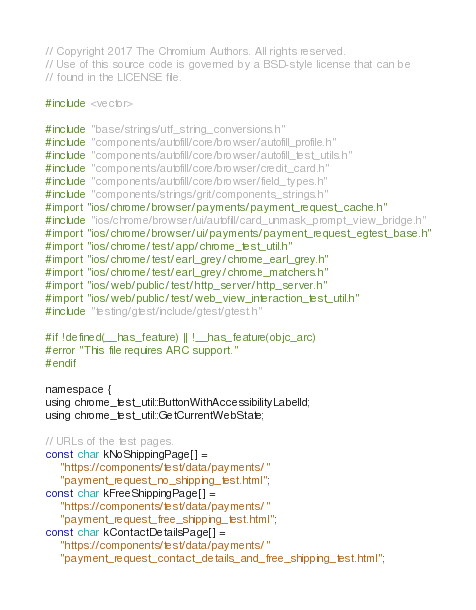Convert code to text. <code><loc_0><loc_0><loc_500><loc_500><_ObjectiveC_>// Copyright 2017 The Chromium Authors. All rights reserved.
// Use of this source code is governed by a BSD-style license that can be
// found in the LICENSE file.

#include <vector>

#include "base/strings/utf_string_conversions.h"
#include "components/autofill/core/browser/autofill_profile.h"
#include "components/autofill/core/browser/autofill_test_utils.h"
#include "components/autofill/core/browser/credit_card.h"
#include "components/autofill/core/browser/field_types.h"
#include "components/strings/grit/components_strings.h"
#import "ios/chrome/browser/payments/payment_request_cache.h"
#include "ios/chrome/browser/ui/autofill/card_unmask_prompt_view_bridge.h"
#import "ios/chrome/browser/ui/payments/payment_request_egtest_base.h"
#import "ios/chrome/test/app/chrome_test_util.h"
#import "ios/chrome/test/earl_grey/chrome_earl_grey.h"
#import "ios/chrome/test/earl_grey/chrome_matchers.h"
#import "ios/web/public/test/http_server/http_server.h"
#import "ios/web/public/test/web_view_interaction_test_util.h"
#include "testing/gtest/include/gtest/gtest.h"

#if !defined(__has_feature) || !__has_feature(objc_arc)
#error "This file requires ARC support."
#endif

namespace {
using chrome_test_util::ButtonWithAccessibilityLabelId;
using chrome_test_util::GetCurrentWebState;

// URLs of the test pages.
const char kNoShippingPage[] =
    "https://components/test/data/payments/"
    "payment_request_no_shipping_test.html";
const char kFreeShippingPage[] =
    "https://components/test/data/payments/"
    "payment_request_free_shipping_test.html";
const char kContactDetailsPage[] =
    "https://components/test/data/payments/"
    "payment_request_contact_details_and_free_shipping_test.html";</code> 